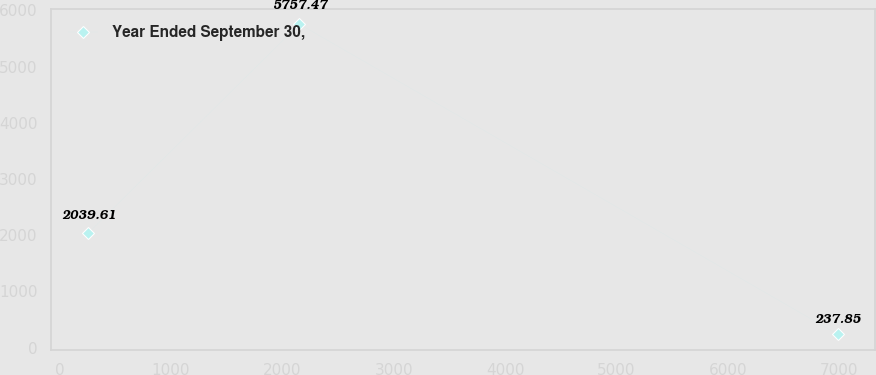Convert chart to OTSL. <chart><loc_0><loc_0><loc_500><loc_500><line_chart><ecel><fcel>Year Ended September 30,<nl><fcel>258.33<fcel>2039.61<nl><fcel>2152.93<fcel>5757.47<nl><fcel>6986.86<fcel>237.85<nl></chart> 